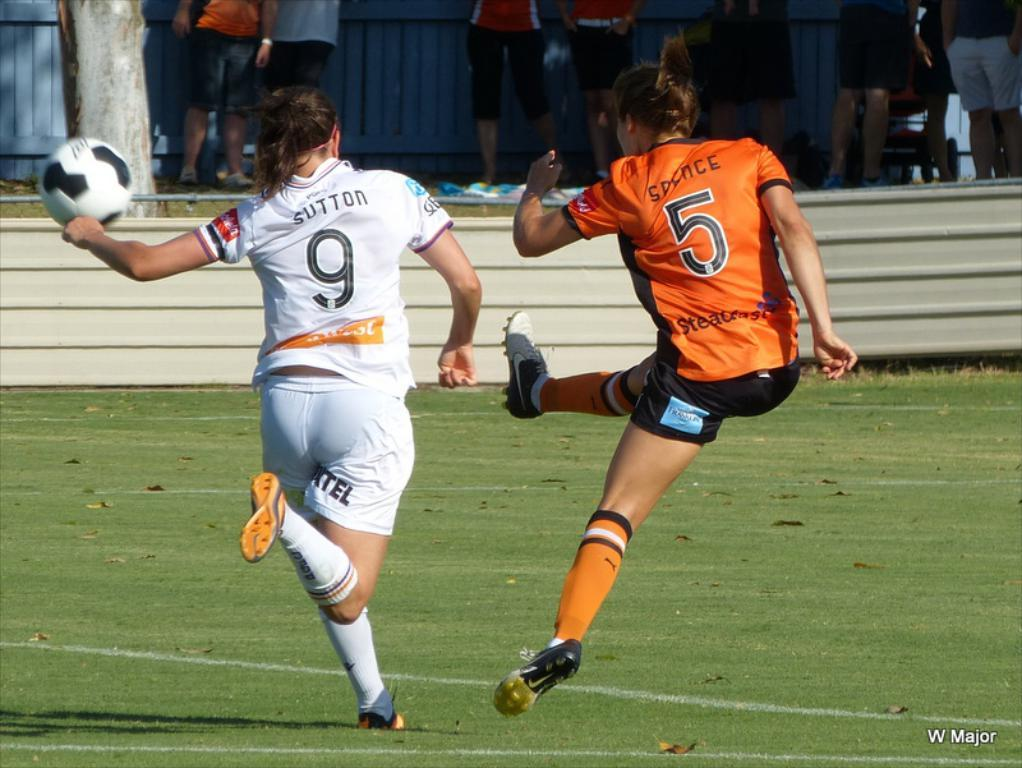<image>
Describe the image concisely. Soccer player wearing number 5 kicking with her leg out. 